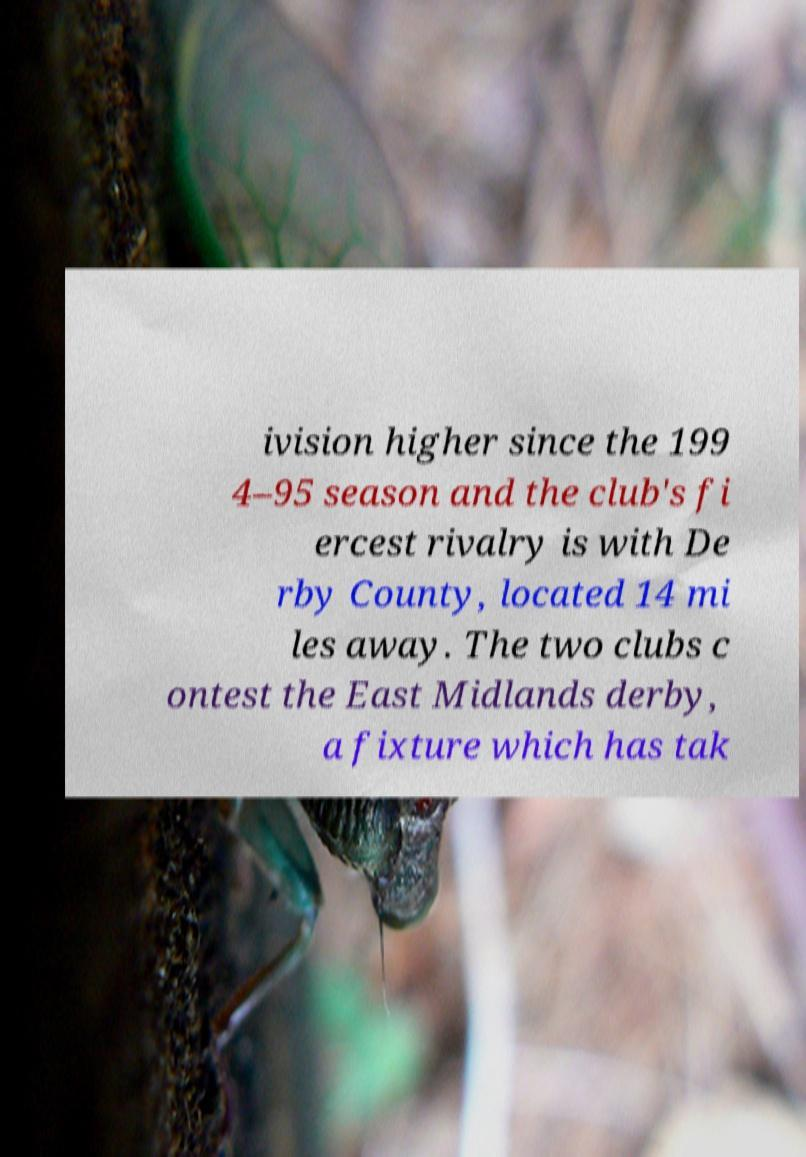For documentation purposes, I need the text within this image transcribed. Could you provide that? ivision higher since the 199 4–95 season and the club's fi ercest rivalry is with De rby County, located 14 mi les away. The two clubs c ontest the East Midlands derby, a fixture which has tak 